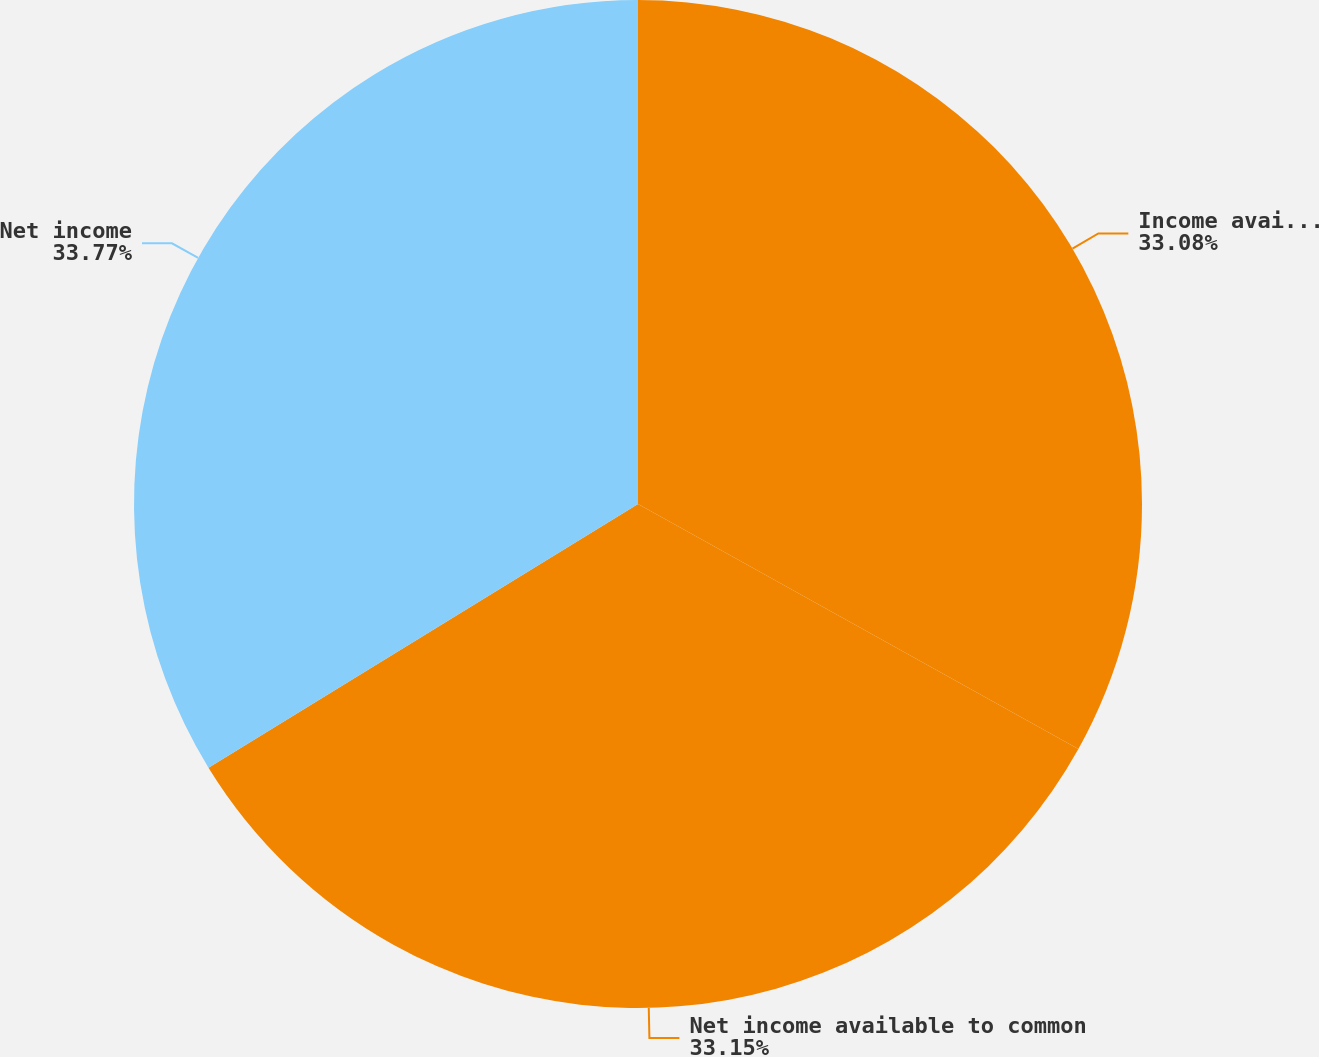<chart> <loc_0><loc_0><loc_500><loc_500><pie_chart><fcel>Income available to common<fcel>Net income available to common<fcel>Net income<nl><fcel>33.08%<fcel>33.15%<fcel>33.76%<nl></chart> 